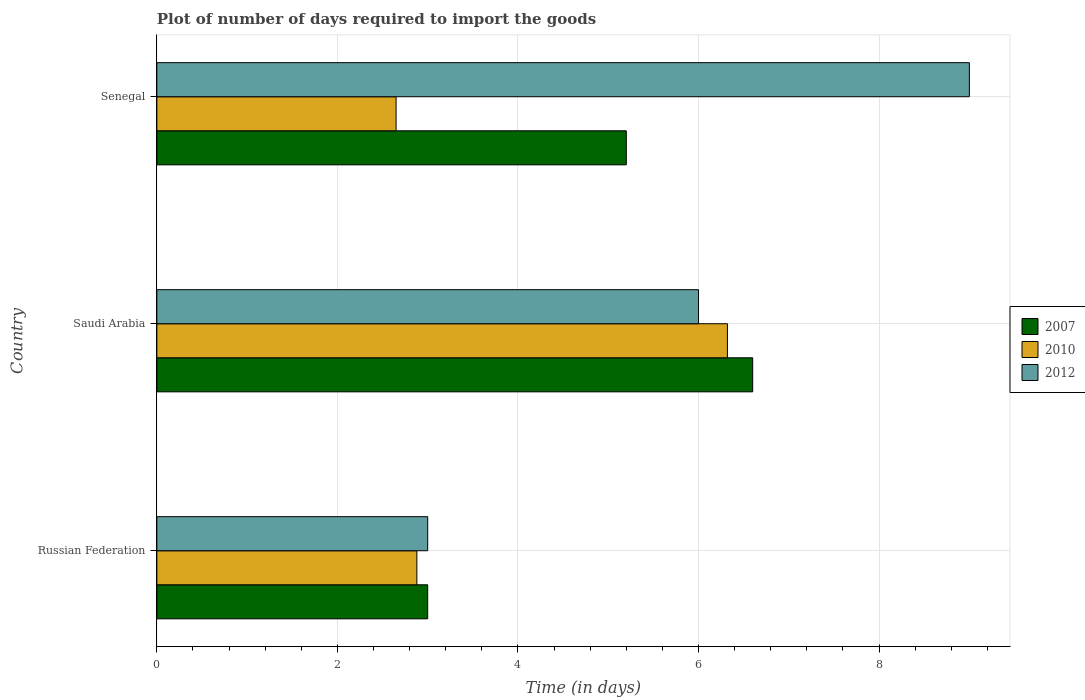How many groups of bars are there?
Make the answer very short. 3. How many bars are there on the 3rd tick from the top?
Give a very brief answer. 3. How many bars are there on the 3rd tick from the bottom?
Give a very brief answer. 3. What is the label of the 1st group of bars from the top?
Provide a short and direct response. Senegal. What is the time required to import goods in 2010 in Senegal?
Offer a very short reply. 2.65. Across all countries, what is the maximum time required to import goods in 2012?
Provide a short and direct response. 9. Across all countries, what is the minimum time required to import goods in 2010?
Provide a short and direct response. 2.65. In which country was the time required to import goods in 2012 maximum?
Keep it short and to the point. Senegal. In which country was the time required to import goods in 2012 minimum?
Your answer should be very brief. Russian Federation. What is the total time required to import goods in 2012 in the graph?
Offer a terse response. 18. What is the difference between the time required to import goods in 2012 in Saudi Arabia and that in Senegal?
Offer a very short reply. -3. What is the difference between the time required to import goods in 2007 in Russian Federation and the time required to import goods in 2012 in Saudi Arabia?
Give a very brief answer. -3. What is the difference between the time required to import goods in 2007 and time required to import goods in 2012 in Russian Federation?
Offer a very short reply. 0. In how many countries, is the time required to import goods in 2007 greater than 5.2 days?
Your response must be concise. 1. What is the ratio of the time required to import goods in 2012 in Russian Federation to that in Senegal?
Your answer should be compact. 0.33. Is the time required to import goods in 2012 in Russian Federation less than that in Senegal?
Your answer should be very brief. Yes. What is the difference between the highest and the second highest time required to import goods in 2010?
Offer a terse response. 3.44. What is the difference between the highest and the lowest time required to import goods in 2010?
Keep it short and to the point. 3.67. Is it the case that in every country, the sum of the time required to import goods in 2012 and time required to import goods in 2010 is greater than the time required to import goods in 2007?
Provide a short and direct response. Yes. Are all the bars in the graph horizontal?
Keep it short and to the point. Yes. How many countries are there in the graph?
Offer a terse response. 3. What is the difference between two consecutive major ticks on the X-axis?
Your answer should be compact. 2. Does the graph contain any zero values?
Your answer should be compact. No. What is the title of the graph?
Provide a succinct answer. Plot of number of days required to import the goods. What is the label or title of the X-axis?
Offer a very short reply. Time (in days). What is the Time (in days) in 2007 in Russian Federation?
Give a very brief answer. 3. What is the Time (in days) of 2010 in Russian Federation?
Give a very brief answer. 2.88. What is the Time (in days) in 2012 in Russian Federation?
Ensure brevity in your answer.  3. What is the Time (in days) in 2010 in Saudi Arabia?
Your answer should be compact. 6.32. What is the Time (in days) of 2010 in Senegal?
Your response must be concise. 2.65. What is the Time (in days) in 2012 in Senegal?
Ensure brevity in your answer.  9. Across all countries, what is the maximum Time (in days) in 2007?
Offer a terse response. 6.6. Across all countries, what is the maximum Time (in days) in 2010?
Ensure brevity in your answer.  6.32. Across all countries, what is the maximum Time (in days) in 2012?
Offer a terse response. 9. Across all countries, what is the minimum Time (in days) of 2007?
Your response must be concise. 3. Across all countries, what is the minimum Time (in days) of 2010?
Your answer should be compact. 2.65. Across all countries, what is the minimum Time (in days) in 2012?
Ensure brevity in your answer.  3. What is the total Time (in days) in 2010 in the graph?
Offer a terse response. 11.85. What is the difference between the Time (in days) in 2007 in Russian Federation and that in Saudi Arabia?
Provide a succinct answer. -3.6. What is the difference between the Time (in days) in 2010 in Russian Federation and that in Saudi Arabia?
Your answer should be very brief. -3.44. What is the difference between the Time (in days) in 2007 in Russian Federation and that in Senegal?
Give a very brief answer. -2.2. What is the difference between the Time (in days) of 2010 in Russian Federation and that in Senegal?
Your response must be concise. 0.23. What is the difference between the Time (in days) in 2007 in Saudi Arabia and that in Senegal?
Give a very brief answer. 1.4. What is the difference between the Time (in days) of 2010 in Saudi Arabia and that in Senegal?
Give a very brief answer. 3.67. What is the difference between the Time (in days) of 2007 in Russian Federation and the Time (in days) of 2010 in Saudi Arabia?
Keep it short and to the point. -3.32. What is the difference between the Time (in days) in 2010 in Russian Federation and the Time (in days) in 2012 in Saudi Arabia?
Ensure brevity in your answer.  -3.12. What is the difference between the Time (in days) of 2007 in Russian Federation and the Time (in days) of 2012 in Senegal?
Offer a terse response. -6. What is the difference between the Time (in days) in 2010 in Russian Federation and the Time (in days) in 2012 in Senegal?
Give a very brief answer. -6.12. What is the difference between the Time (in days) in 2007 in Saudi Arabia and the Time (in days) in 2010 in Senegal?
Your answer should be very brief. 3.95. What is the difference between the Time (in days) of 2010 in Saudi Arabia and the Time (in days) of 2012 in Senegal?
Ensure brevity in your answer.  -2.68. What is the average Time (in days) of 2007 per country?
Your answer should be compact. 4.93. What is the average Time (in days) of 2010 per country?
Offer a terse response. 3.95. What is the average Time (in days) of 2012 per country?
Your answer should be compact. 6. What is the difference between the Time (in days) of 2007 and Time (in days) of 2010 in Russian Federation?
Your answer should be compact. 0.12. What is the difference between the Time (in days) of 2010 and Time (in days) of 2012 in Russian Federation?
Your response must be concise. -0.12. What is the difference between the Time (in days) of 2007 and Time (in days) of 2010 in Saudi Arabia?
Give a very brief answer. 0.28. What is the difference between the Time (in days) in 2007 and Time (in days) in 2012 in Saudi Arabia?
Your response must be concise. 0.6. What is the difference between the Time (in days) in 2010 and Time (in days) in 2012 in Saudi Arabia?
Provide a succinct answer. 0.32. What is the difference between the Time (in days) in 2007 and Time (in days) in 2010 in Senegal?
Make the answer very short. 2.55. What is the difference between the Time (in days) in 2007 and Time (in days) in 2012 in Senegal?
Offer a very short reply. -3.8. What is the difference between the Time (in days) in 2010 and Time (in days) in 2012 in Senegal?
Your response must be concise. -6.35. What is the ratio of the Time (in days) in 2007 in Russian Federation to that in Saudi Arabia?
Your answer should be very brief. 0.45. What is the ratio of the Time (in days) of 2010 in Russian Federation to that in Saudi Arabia?
Offer a very short reply. 0.46. What is the ratio of the Time (in days) in 2007 in Russian Federation to that in Senegal?
Make the answer very short. 0.58. What is the ratio of the Time (in days) in 2010 in Russian Federation to that in Senegal?
Keep it short and to the point. 1.09. What is the ratio of the Time (in days) in 2012 in Russian Federation to that in Senegal?
Your answer should be compact. 0.33. What is the ratio of the Time (in days) in 2007 in Saudi Arabia to that in Senegal?
Keep it short and to the point. 1.27. What is the ratio of the Time (in days) in 2010 in Saudi Arabia to that in Senegal?
Ensure brevity in your answer.  2.38. What is the difference between the highest and the second highest Time (in days) of 2010?
Provide a short and direct response. 3.44. What is the difference between the highest and the lowest Time (in days) of 2007?
Keep it short and to the point. 3.6. What is the difference between the highest and the lowest Time (in days) of 2010?
Provide a succinct answer. 3.67. What is the difference between the highest and the lowest Time (in days) of 2012?
Your response must be concise. 6. 